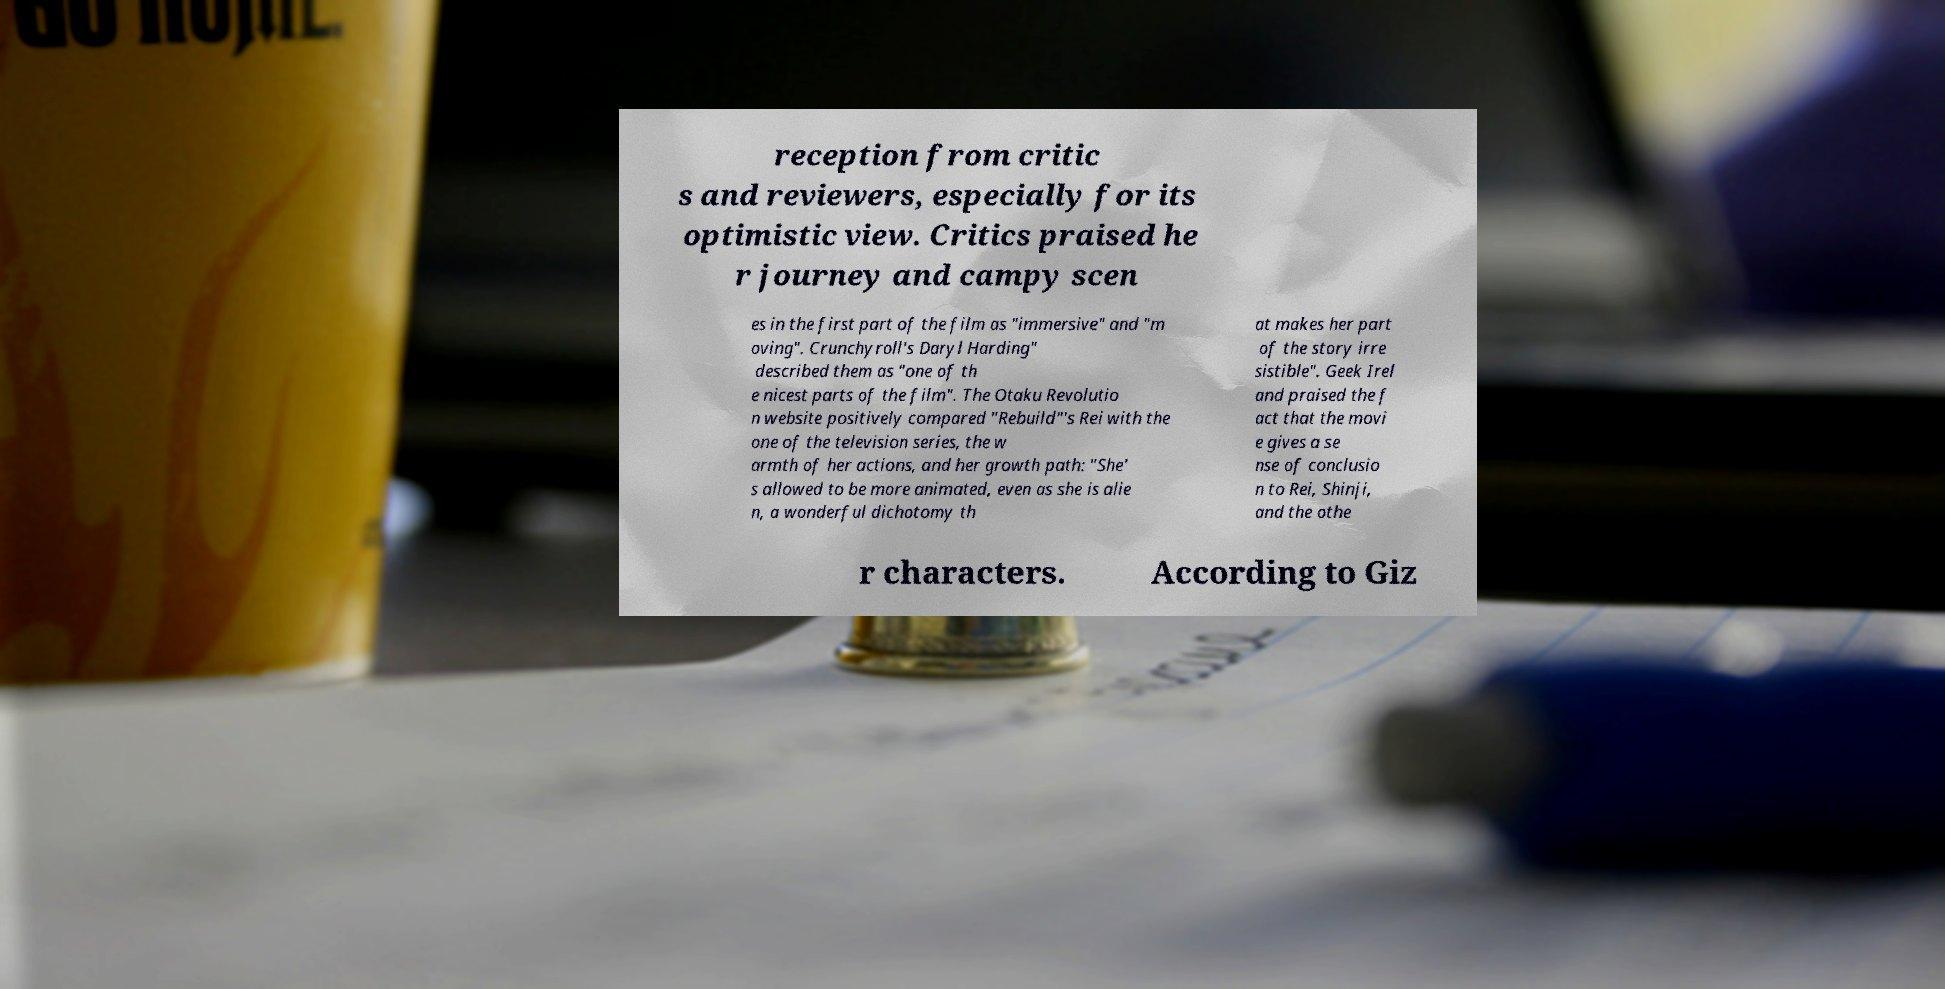What messages or text are displayed in this image? I need them in a readable, typed format. reception from critic s and reviewers, especially for its optimistic view. Critics praised he r journey and campy scen es in the first part of the film as "immersive" and "m oving". Crunchyroll's Daryl Harding" described them as "one of th e nicest parts of the film". The Otaku Revolutio n website positively compared "Rebuild"'s Rei with the one of the television series, the w armth of her actions, and her growth path: "She' s allowed to be more animated, even as she is alie n, a wonderful dichotomy th at makes her part of the story irre sistible". Geek Irel and praised the f act that the movi e gives a se nse of conclusio n to Rei, Shinji, and the othe r characters. According to Giz 